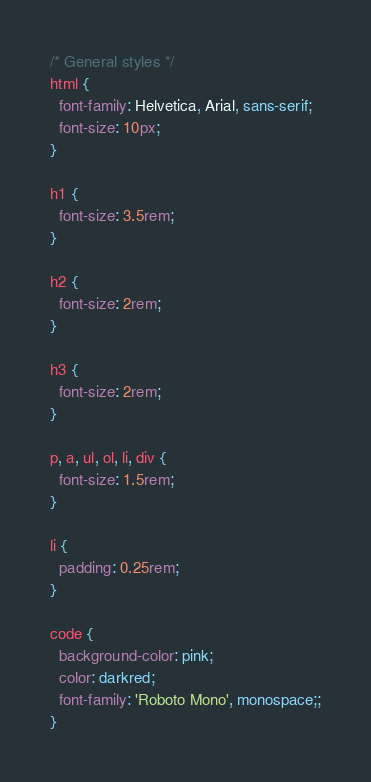Convert code to text. <code><loc_0><loc_0><loc_500><loc_500><_CSS_>/* General styles */
html {
  font-family: Helvetica, Arial, sans-serif;
  font-size: 10px;
}

h1 {
  font-size: 3.5rem;
}

h2 {
  font-size: 2rem;
}

h3 {
  font-size: 2rem;
}

p, a, ul, ol, li, div {
  font-size: 1.5rem;
}

li {
  padding: 0.25rem;
}

code {
  background-color: pink;
  color: darkred;
  font-family: 'Roboto Mono', monospace;;
}
</code> 